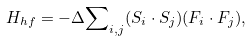<formula> <loc_0><loc_0><loc_500><loc_500>H _ { h f } = - \Delta { \sum } _ { i , j } ( { S } _ { i } \cdot { S } _ { j } ) ( { F } _ { i } \cdot { F } _ { j } ) ,</formula> 